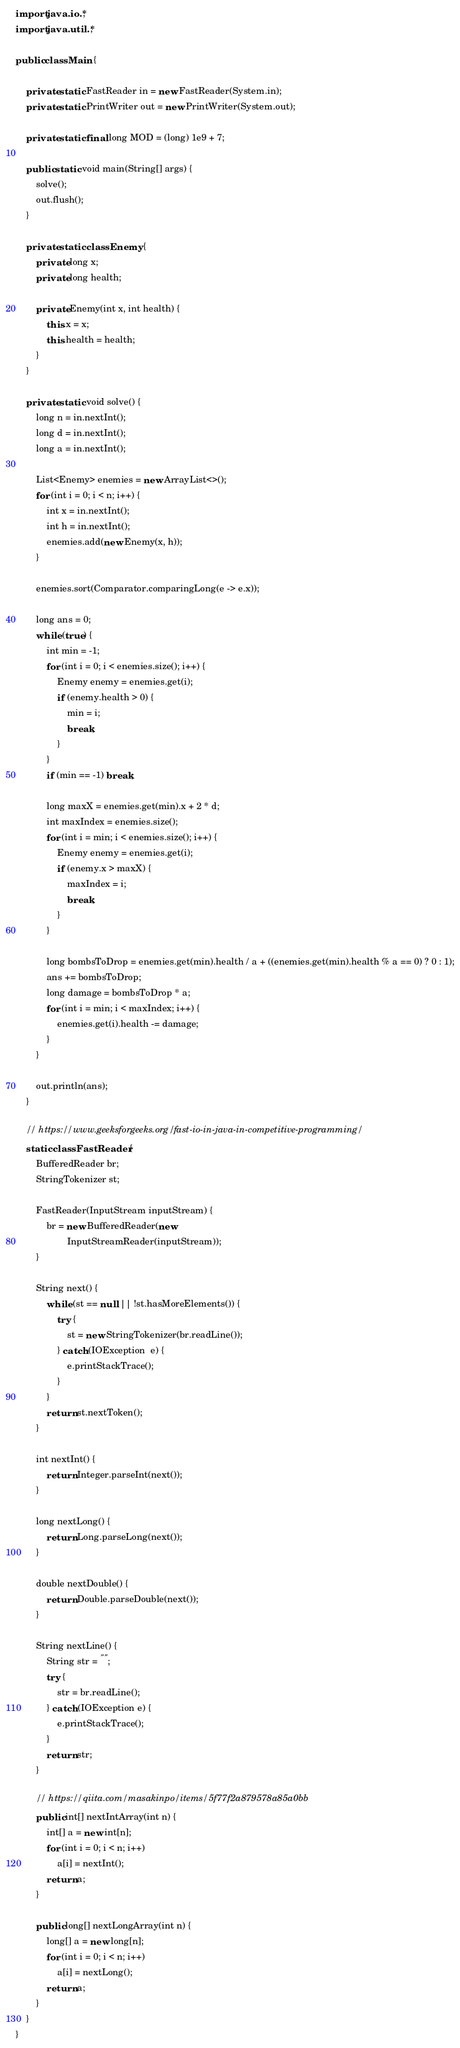<code> <loc_0><loc_0><loc_500><loc_500><_Java_>import java.io.*;
import java.util.*;

public class Main {

    private static FastReader in = new FastReader(System.in);
    private static PrintWriter out = new PrintWriter(System.out);

    private static final long MOD = (long) 1e9 + 7;

    public static void main(String[] args) {
        solve();
        out.flush();
    }

    private static class Enemy {
        private long x;
        private long health;

        private Enemy(int x, int health) {
            this.x = x;
            this.health = health;
        }
    }

    private static void solve() {
        long n = in.nextInt();
        long d = in.nextInt();
        long a = in.nextInt();

        List<Enemy> enemies = new ArrayList<>();
        for (int i = 0; i < n; i++) {
            int x = in.nextInt();
            int h = in.nextInt();
            enemies.add(new Enemy(x, h));
        }

        enemies.sort(Comparator.comparingLong(e -> e.x));

        long ans = 0;
        while (true) {
            int min = -1;
            for (int i = 0; i < enemies.size(); i++) {
                Enemy enemy = enemies.get(i);
                if (enemy.health > 0) {
                    min = i;
                    break;
                }
            }
            if (min == -1) break;

            long maxX = enemies.get(min).x + 2 * d;
            int maxIndex = enemies.size();
            for (int i = min; i < enemies.size(); i++) {
                Enemy enemy = enemies.get(i);
                if (enemy.x > maxX) {
                    maxIndex = i;
                    break;
                }
            }

            long bombsToDrop = enemies.get(min).health / a + ((enemies.get(min).health % a == 0) ? 0 : 1);
            ans += bombsToDrop;
            long damage = bombsToDrop * a;
            for (int i = min; i < maxIndex; i++) {
                enemies.get(i).health -= damage;
            }
        }

        out.println(ans);
    }

    // https://www.geeksforgeeks.org/fast-io-in-java-in-competitive-programming/
    static class FastReader {
        BufferedReader br;
        StringTokenizer st;

        FastReader(InputStream inputStream) {
            br = new BufferedReader(new
                    InputStreamReader(inputStream));
        }

        String next() {
            while (st == null || !st.hasMoreElements()) {
                try {
                    st = new StringTokenizer(br.readLine());
                } catch (IOException  e) {
                    e.printStackTrace();
                }
            }
            return st.nextToken();
        }

        int nextInt() {
            return Integer.parseInt(next());
        }

        long nextLong() {
            return Long.parseLong(next());
        }

        double nextDouble() {
            return Double.parseDouble(next());
        }

        String nextLine() {
            String str = "";
            try {
                str = br.readLine();
            } catch (IOException e) {
                e.printStackTrace();
            }
            return str;
        }

        // https://qiita.com/masakinpo/items/5f77f2a879578a85a0bb
        public int[] nextIntArray(int n) {
            int[] a = new int[n];
            for (int i = 0; i < n; i++)
                a[i] = nextInt();
            return a;
        }

        public long[] nextLongArray(int n) {
            long[] a = new long[n];
            for (int i = 0; i < n; i++)
                a[i] = nextLong();
            return a;
        }
    }
}
</code> 